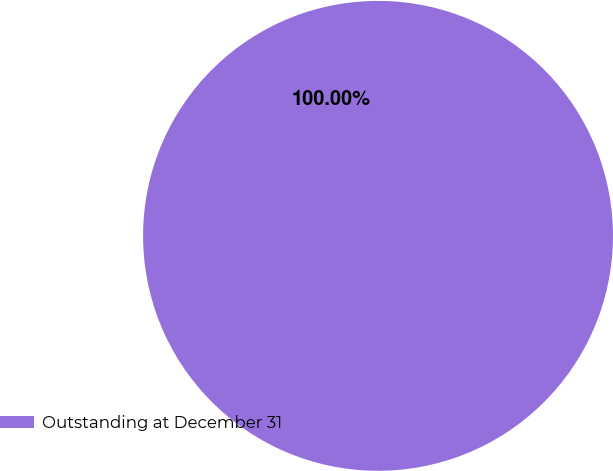Convert chart to OTSL. <chart><loc_0><loc_0><loc_500><loc_500><pie_chart><fcel>Outstanding at December 31<nl><fcel>100.0%<nl></chart> 